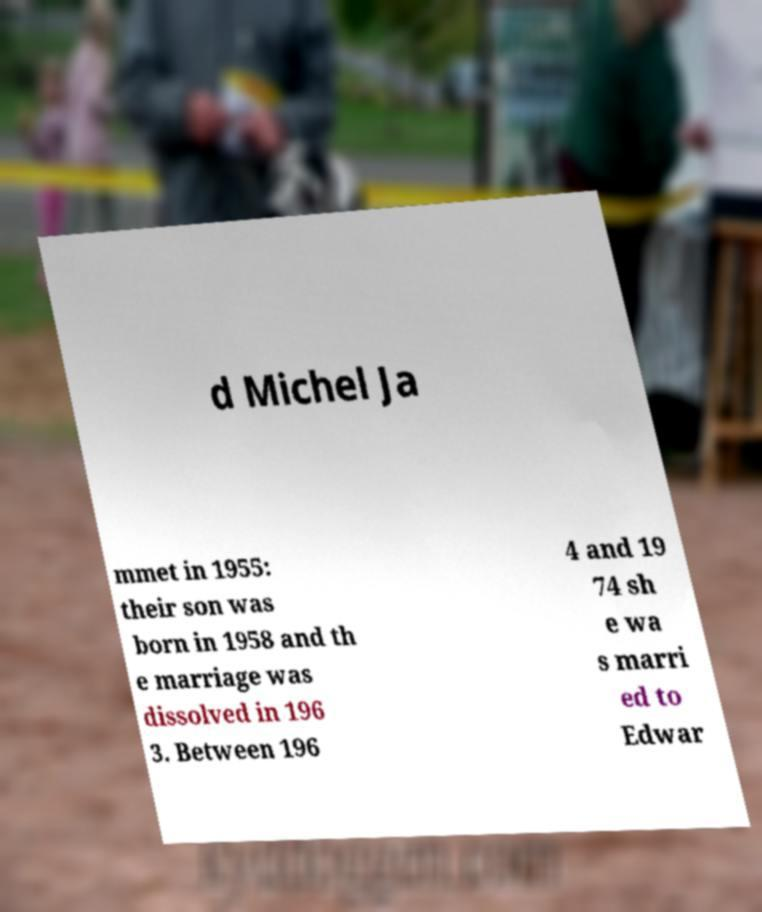Could you assist in decoding the text presented in this image and type it out clearly? d Michel Ja mmet in 1955: their son was born in 1958 and th e marriage was dissolved in 196 3. Between 196 4 and 19 74 sh e wa s marri ed to Edwar 